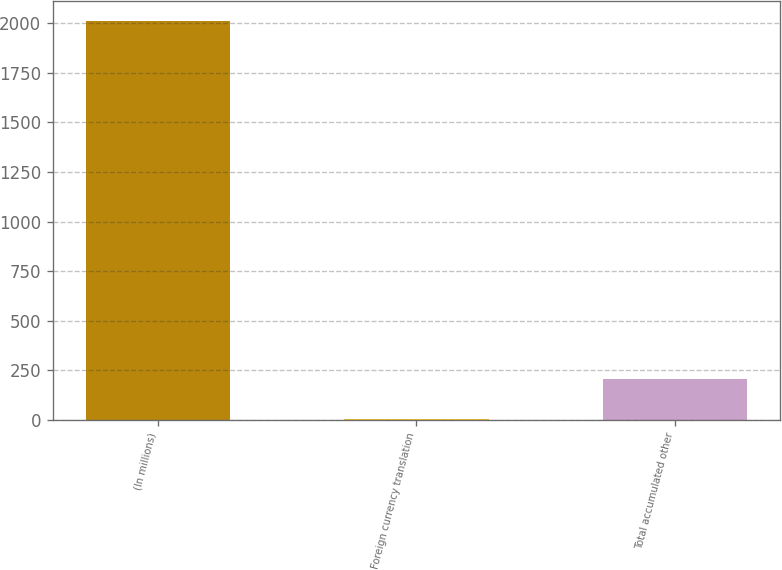Convert chart. <chart><loc_0><loc_0><loc_500><loc_500><bar_chart><fcel>(In millions)<fcel>Foreign currency translation<fcel>Total accumulated other<nl><fcel>2013<fcel>2<fcel>203.1<nl></chart> 